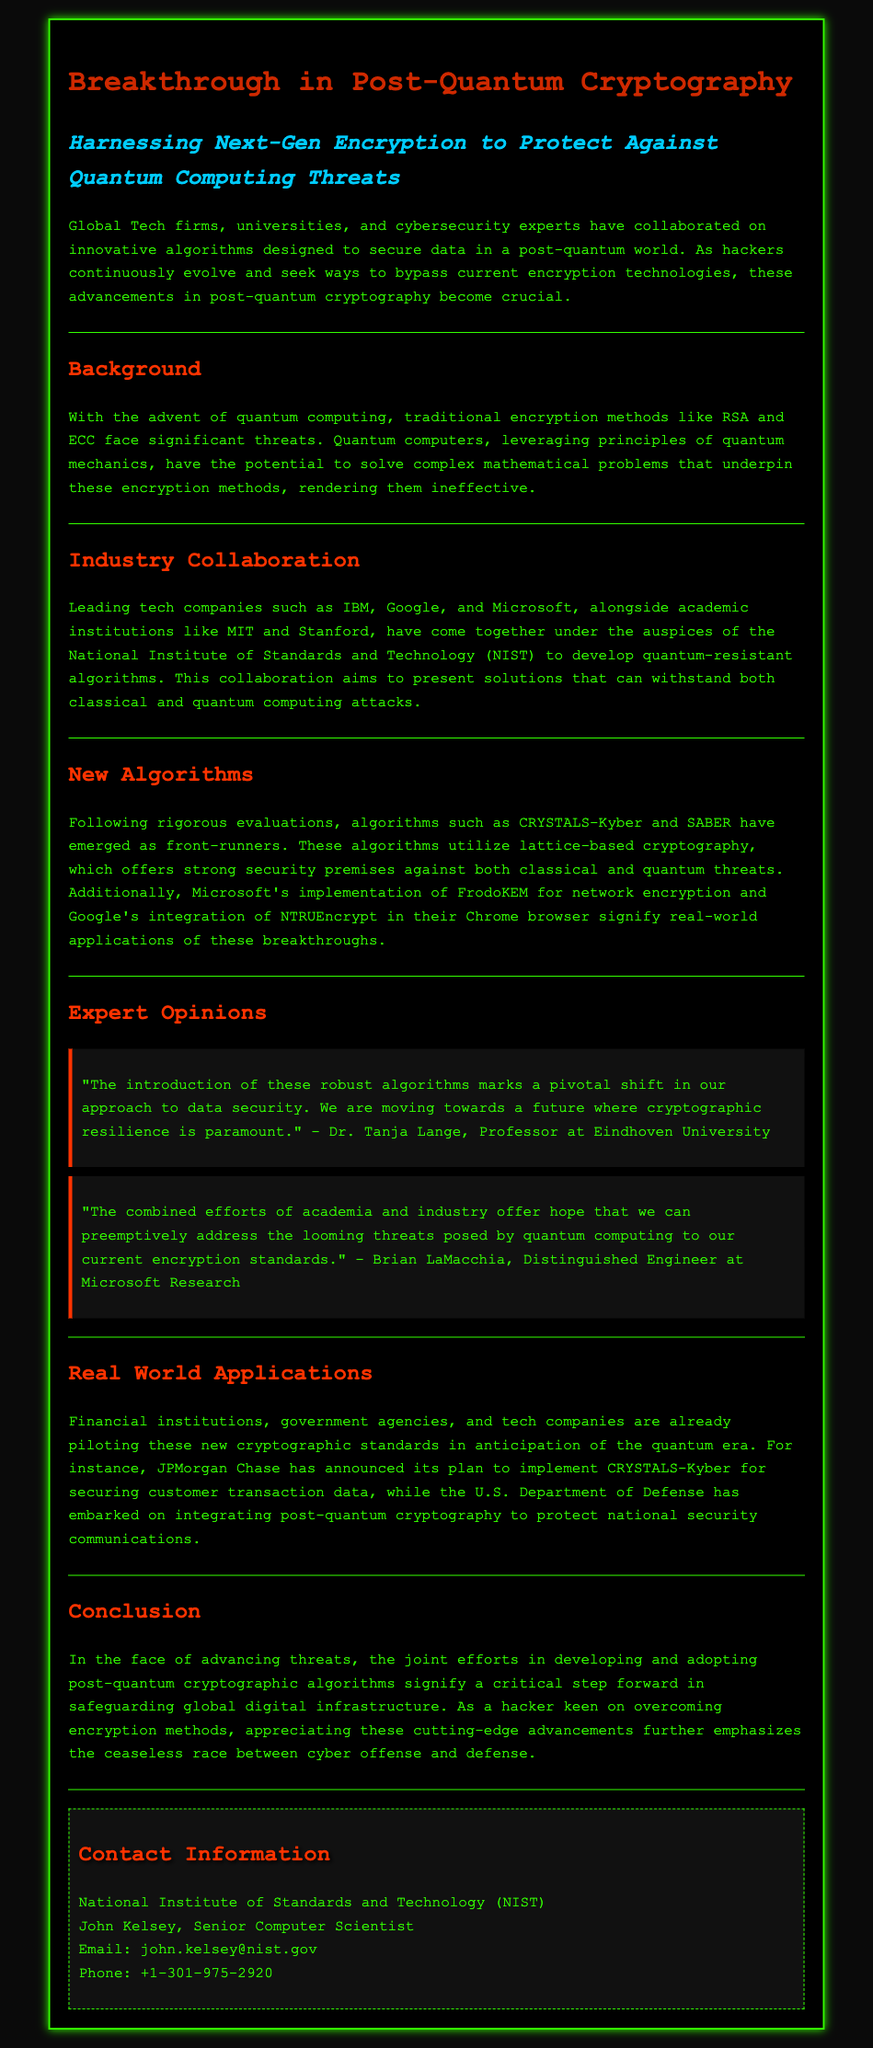What is the title of the press release? The title is explicitly stated at the top of the document and is "Breakthrough in Post-Quantum Cryptography."
Answer: Breakthrough in Post-Quantum Cryptography Which organizations collaborated on the new algorithms? The document mentions leading tech companies and academic institutions, specifically naming IBM, Google, Microsoft, MIT, and Stanford as collaborators.
Answer: IBM, Google, Microsoft, MIT, Stanford What are the names of the two emerging algorithms? The two algorithms highlighted in the document as front-runners are named in the section discussing new algorithms.
Answer: CRYSTALS-Kyber and SABER Who is quoted in the expert opinions section? The document lists quotes from Dr. Tanja Lange and Brian LaMacchia, indicating their respective roles and opinions.
Answer: Dr. Tanja Lange, Brian LaMacchia What industry application does JPMorgan Chase plan to implement? The document specifies JPMorgan Chase's intention to use a particular algorithm for a specific purpose, which is stated in the real-world applications section.
Answer: CRYSTALS-Kyber for securing customer transaction data What threat do traditional encryption methods face? The document cites quantum computing as the primary threat to traditional encryption methods like RSA and ECC.
Answer: Quantum computing How is the new algorithm implementation by Microsoft described? The document describes Microsoft's specific application of a new algorithm, indicating its function in network encryption.
Answer: FrodoKEM for network encryption Which organization is associated with the contact information? At the end of the document, the contact information is provided, identifying the organization responsible for the press release.
Answer: National Institute of Standards and Technology (NIST) 